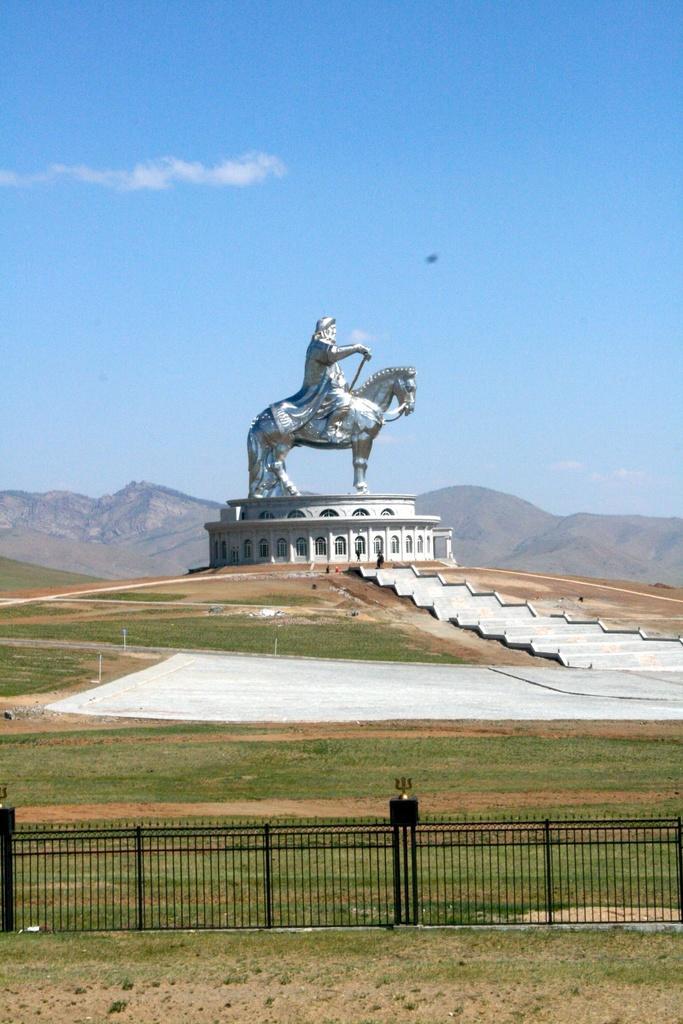Please provide a concise description of this image. Here we can see a sculpture. This is grass and there is a fence. In the background we can see mountain and sky. 